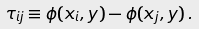Convert formula to latex. <formula><loc_0><loc_0><loc_500><loc_500>\tau _ { i j } \equiv \phi ( x _ { i } , y ) - \phi ( x _ { j } , y ) \, .</formula> 